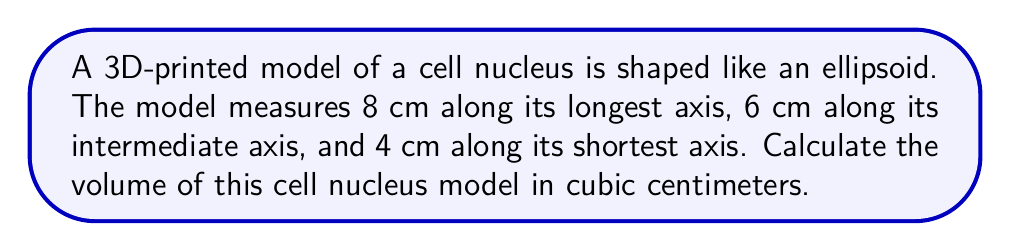Solve this math problem. To solve this problem, we'll use the formula for the volume of an ellipsoid:

$$V = \frac{4}{3}\pi abc$$

Where:
$a$ = half of the longest axis
$b$ = half of the intermediate axis
$c$ = half of the shortest axis

Step 1: Determine the values of $a$, $b$, and $c$:
$a = 8/2 = 4$ cm
$b = 6/2 = 3$ cm
$c = 4/2 = 2$ cm

Step 2: Substitute these values into the formula:
$$V = \frac{4}{3}\pi(4)(3)(2)$$

Step 3: Simplify:
$$V = \frac{4}{3}\pi(24)$$
$$V = 32\pi$$

Step 4: Calculate the final value (rounded to two decimal places):
$$V \approx 100.53 \text{ cm}^3$$
Answer: $100.53 \text{ cm}^3$ 